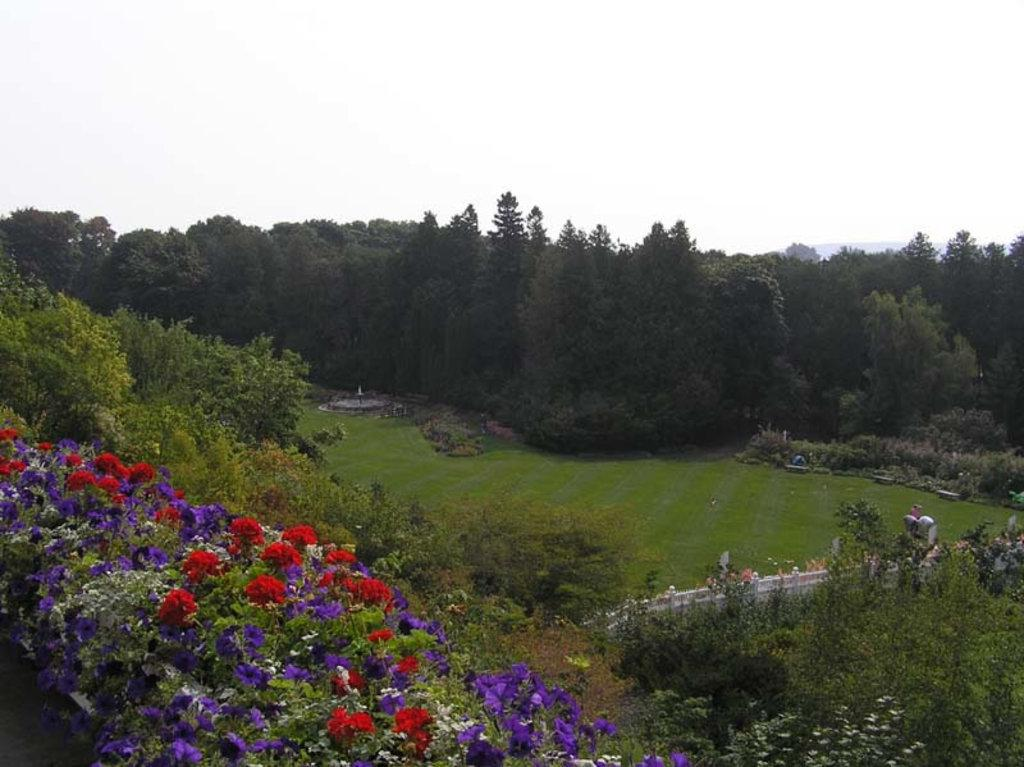What type of vegetation is on the left side of the image? There are flowering plants on the left side of the image. What other types of vegetation can be seen in the image? There are trees in the image. What is the purpose of the fencing in the image? The fencing in the image serves as a barrier or boundary. What type of ground cover is present in the image? There is grass in the image. What can be seen in the background of the image? There are trees and the sky visible in the background of the image. What type of building can be seen in the image? There is no building present in the image; it features flowering plants, trees, fencing, grass, and a sky background. Is there a bridge visible in the image? No, there is no bridge present in the image. 